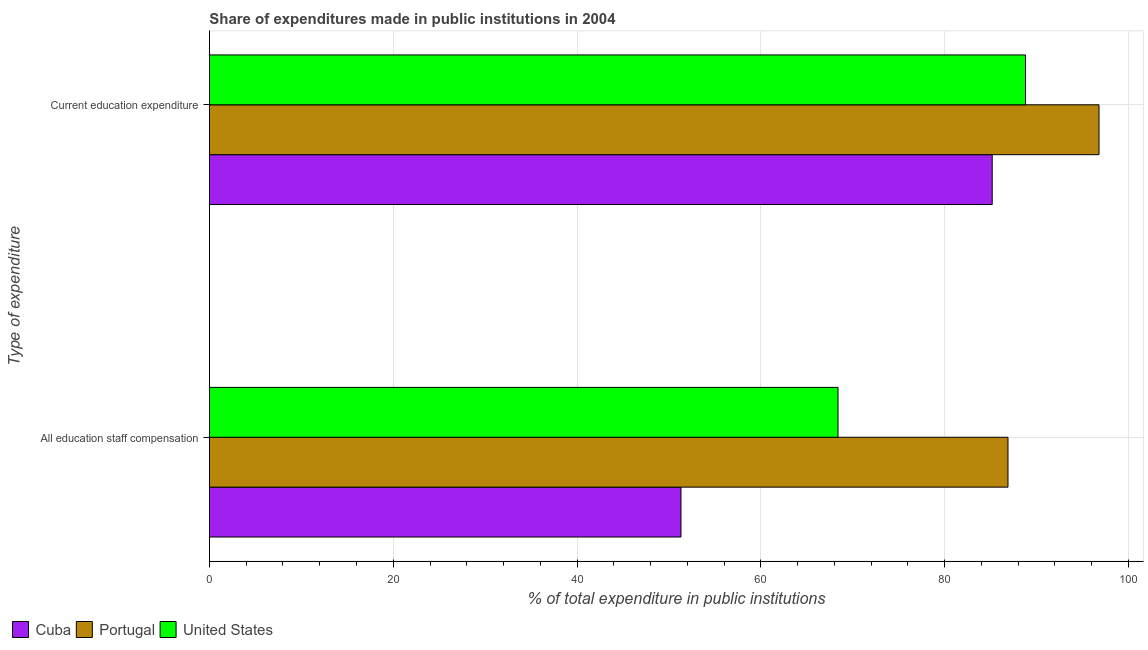Are the number of bars per tick equal to the number of legend labels?
Keep it short and to the point. Yes. Are the number of bars on each tick of the Y-axis equal?
Provide a short and direct response. Yes. How many bars are there on the 2nd tick from the bottom?
Your answer should be very brief. 3. What is the label of the 1st group of bars from the top?
Your answer should be compact. Current education expenditure. What is the expenditure in staff compensation in United States?
Ensure brevity in your answer.  68.39. Across all countries, what is the maximum expenditure in education?
Offer a very short reply. 96.79. Across all countries, what is the minimum expenditure in education?
Provide a short and direct response. 85.17. In which country was the expenditure in staff compensation maximum?
Ensure brevity in your answer.  Portugal. In which country was the expenditure in education minimum?
Offer a very short reply. Cuba. What is the total expenditure in education in the graph?
Your response must be concise. 270.76. What is the difference between the expenditure in staff compensation in Portugal and that in Cuba?
Keep it short and to the point. 35.58. What is the difference between the expenditure in education in United States and the expenditure in staff compensation in Cuba?
Ensure brevity in your answer.  37.49. What is the average expenditure in staff compensation per country?
Your response must be concise. 68.86. What is the difference between the expenditure in education and expenditure in staff compensation in Portugal?
Provide a succinct answer. 9.9. What is the ratio of the expenditure in education in United States to that in Portugal?
Your answer should be very brief. 0.92. What does the 3rd bar from the top in Current education expenditure represents?
Ensure brevity in your answer.  Cuba. What does the 1st bar from the bottom in Current education expenditure represents?
Your answer should be compact. Cuba. What is the difference between two consecutive major ticks on the X-axis?
Keep it short and to the point. 20. What is the title of the graph?
Give a very brief answer. Share of expenditures made in public institutions in 2004. Does "Saudi Arabia" appear as one of the legend labels in the graph?
Ensure brevity in your answer.  No. What is the label or title of the X-axis?
Provide a short and direct response. % of total expenditure in public institutions. What is the label or title of the Y-axis?
Your response must be concise. Type of expenditure. What is the % of total expenditure in public institutions of Cuba in All education staff compensation?
Ensure brevity in your answer.  51.31. What is the % of total expenditure in public institutions in Portugal in All education staff compensation?
Provide a short and direct response. 86.89. What is the % of total expenditure in public institutions of United States in All education staff compensation?
Make the answer very short. 68.39. What is the % of total expenditure in public institutions in Cuba in Current education expenditure?
Provide a short and direct response. 85.17. What is the % of total expenditure in public institutions in Portugal in Current education expenditure?
Ensure brevity in your answer.  96.79. What is the % of total expenditure in public institutions of United States in Current education expenditure?
Ensure brevity in your answer.  88.8. Across all Type of expenditure, what is the maximum % of total expenditure in public institutions of Cuba?
Ensure brevity in your answer.  85.17. Across all Type of expenditure, what is the maximum % of total expenditure in public institutions of Portugal?
Offer a terse response. 96.79. Across all Type of expenditure, what is the maximum % of total expenditure in public institutions in United States?
Provide a succinct answer. 88.8. Across all Type of expenditure, what is the minimum % of total expenditure in public institutions in Cuba?
Ensure brevity in your answer.  51.31. Across all Type of expenditure, what is the minimum % of total expenditure in public institutions of Portugal?
Keep it short and to the point. 86.89. Across all Type of expenditure, what is the minimum % of total expenditure in public institutions in United States?
Your response must be concise. 68.39. What is the total % of total expenditure in public institutions of Cuba in the graph?
Make the answer very short. 136.48. What is the total % of total expenditure in public institutions in Portugal in the graph?
Your response must be concise. 183.68. What is the total % of total expenditure in public institutions in United States in the graph?
Provide a succinct answer. 157.19. What is the difference between the % of total expenditure in public institutions of Cuba in All education staff compensation and that in Current education expenditure?
Your response must be concise. -33.86. What is the difference between the % of total expenditure in public institutions in Portugal in All education staff compensation and that in Current education expenditure?
Ensure brevity in your answer.  -9.9. What is the difference between the % of total expenditure in public institutions in United States in All education staff compensation and that in Current education expenditure?
Your answer should be very brief. -20.4. What is the difference between the % of total expenditure in public institutions in Cuba in All education staff compensation and the % of total expenditure in public institutions in Portugal in Current education expenditure?
Give a very brief answer. -45.49. What is the difference between the % of total expenditure in public institutions of Cuba in All education staff compensation and the % of total expenditure in public institutions of United States in Current education expenditure?
Your answer should be very brief. -37.49. What is the difference between the % of total expenditure in public institutions in Portugal in All education staff compensation and the % of total expenditure in public institutions in United States in Current education expenditure?
Ensure brevity in your answer.  -1.91. What is the average % of total expenditure in public institutions in Cuba per Type of expenditure?
Your answer should be very brief. 68.24. What is the average % of total expenditure in public institutions in Portugal per Type of expenditure?
Your response must be concise. 91.84. What is the average % of total expenditure in public institutions of United States per Type of expenditure?
Your answer should be compact. 78.6. What is the difference between the % of total expenditure in public institutions of Cuba and % of total expenditure in public institutions of Portugal in All education staff compensation?
Ensure brevity in your answer.  -35.58. What is the difference between the % of total expenditure in public institutions of Cuba and % of total expenditure in public institutions of United States in All education staff compensation?
Your response must be concise. -17.09. What is the difference between the % of total expenditure in public institutions of Portugal and % of total expenditure in public institutions of United States in All education staff compensation?
Make the answer very short. 18.49. What is the difference between the % of total expenditure in public institutions in Cuba and % of total expenditure in public institutions in Portugal in Current education expenditure?
Keep it short and to the point. -11.62. What is the difference between the % of total expenditure in public institutions in Cuba and % of total expenditure in public institutions in United States in Current education expenditure?
Make the answer very short. -3.62. What is the difference between the % of total expenditure in public institutions of Portugal and % of total expenditure in public institutions of United States in Current education expenditure?
Give a very brief answer. 8. What is the ratio of the % of total expenditure in public institutions of Cuba in All education staff compensation to that in Current education expenditure?
Make the answer very short. 0.6. What is the ratio of the % of total expenditure in public institutions of Portugal in All education staff compensation to that in Current education expenditure?
Ensure brevity in your answer.  0.9. What is the ratio of the % of total expenditure in public institutions in United States in All education staff compensation to that in Current education expenditure?
Offer a terse response. 0.77. What is the difference between the highest and the second highest % of total expenditure in public institutions of Cuba?
Offer a very short reply. 33.86. What is the difference between the highest and the second highest % of total expenditure in public institutions of Portugal?
Your response must be concise. 9.9. What is the difference between the highest and the second highest % of total expenditure in public institutions of United States?
Ensure brevity in your answer.  20.4. What is the difference between the highest and the lowest % of total expenditure in public institutions of Cuba?
Keep it short and to the point. 33.86. What is the difference between the highest and the lowest % of total expenditure in public institutions in Portugal?
Make the answer very short. 9.9. What is the difference between the highest and the lowest % of total expenditure in public institutions of United States?
Provide a succinct answer. 20.4. 